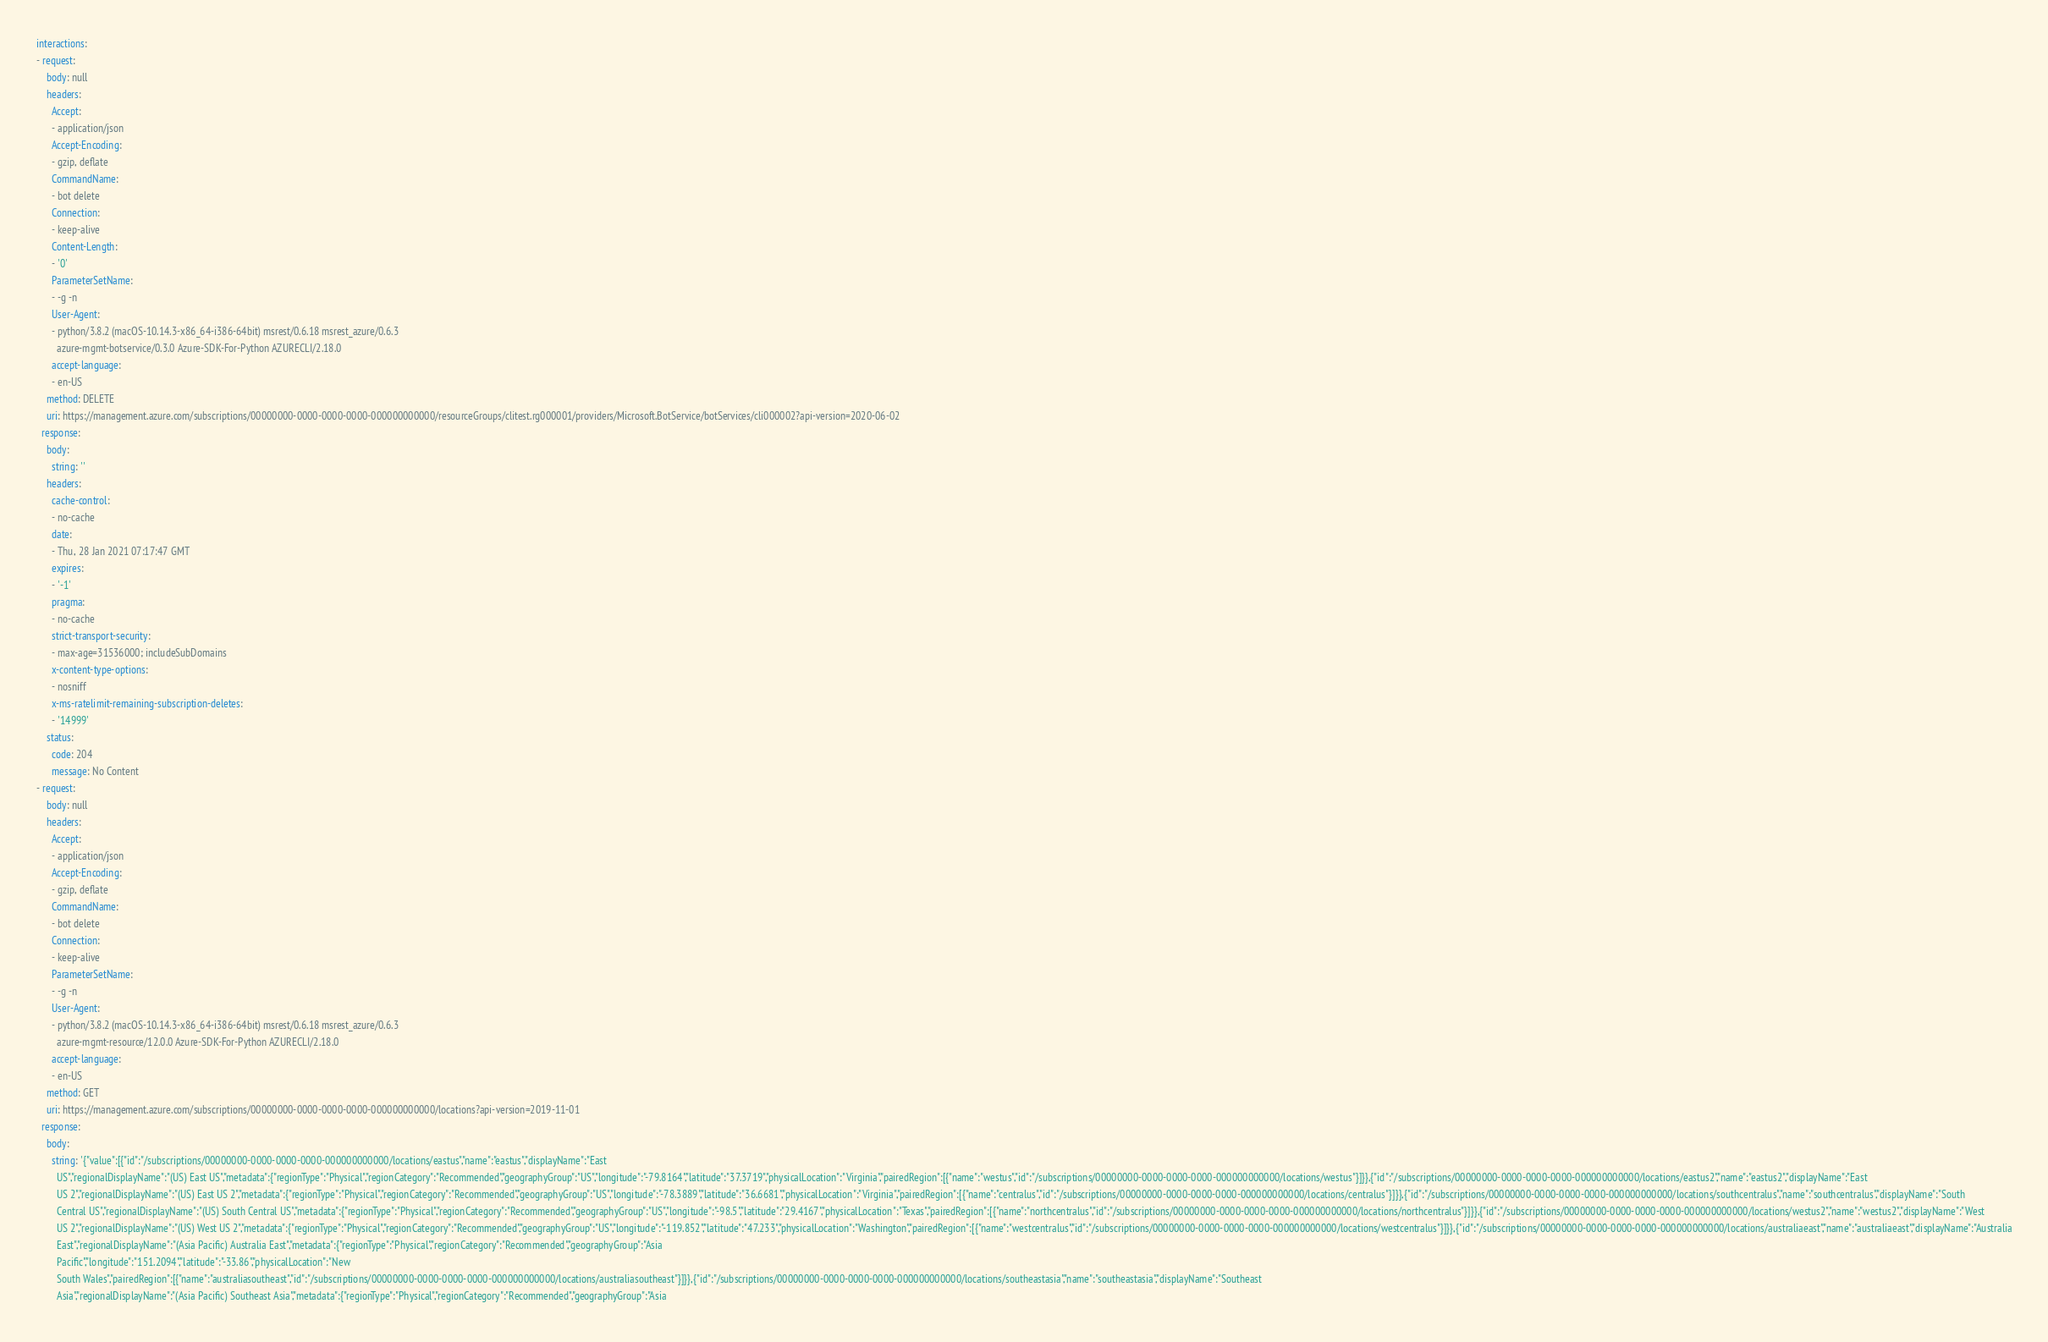Convert code to text. <code><loc_0><loc_0><loc_500><loc_500><_YAML_>interactions:
- request:
    body: null
    headers:
      Accept:
      - application/json
      Accept-Encoding:
      - gzip, deflate
      CommandName:
      - bot delete
      Connection:
      - keep-alive
      Content-Length:
      - '0'
      ParameterSetName:
      - -g -n
      User-Agent:
      - python/3.8.2 (macOS-10.14.3-x86_64-i386-64bit) msrest/0.6.18 msrest_azure/0.6.3
        azure-mgmt-botservice/0.3.0 Azure-SDK-For-Python AZURECLI/2.18.0
      accept-language:
      - en-US
    method: DELETE
    uri: https://management.azure.com/subscriptions/00000000-0000-0000-0000-000000000000/resourceGroups/clitest.rg000001/providers/Microsoft.BotService/botServices/cli000002?api-version=2020-06-02
  response:
    body:
      string: ''
    headers:
      cache-control:
      - no-cache
      date:
      - Thu, 28 Jan 2021 07:17:47 GMT
      expires:
      - '-1'
      pragma:
      - no-cache
      strict-transport-security:
      - max-age=31536000; includeSubDomains
      x-content-type-options:
      - nosniff
      x-ms-ratelimit-remaining-subscription-deletes:
      - '14999'
    status:
      code: 204
      message: No Content
- request:
    body: null
    headers:
      Accept:
      - application/json
      Accept-Encoding:
      - gzip, deflate
      CommandName:
      - bot delete
      Connection:
      - keep-alive
      ParameterSetName:
      - -g -n
      User-Agent:
      - python/3.8.2 (macOS-10.14.3-x86_64-i386-64bit) msrest/0.6.18 msrest_azure/0.6.3
        azure-mgmt-resource/12.0.0 Azure-SDK-For-Python AZURECLI/2.18.0
      accept-language:
      - en-US
    method: GET
    uri: https://management.azure.com/subscriptions/00000000-0000-0000-0000-000000000000/locations?api-version=2019-11-01
  response:
    body:
      string: '{"value":[{"id":"/subscriptions/00000000-0000-0000-0000-000000000000/locations/eastus","name":"eastus","displayName":"East
        US","regionalDisplayName":"(US) East US","metadata":{"regionType":"Physical","regionCategory":"Recommended","geographyGroup":"US","longitude":"-79.8164","latitude":"37.3719","physicalLocation":"Virginia","pairedRegion":[{"name":"westus","id":"/subscriptions/00000000-0000-0000-0000-000000000000/locations/westus"}]}},{"id":"/subscriptions/00000000-0000-0000-0000-000000000000/locations/eastus2","name":"eastus2","displayName":"East
        US 2","regionalDisplayName":"(US) East US 2","metadata":{"regionType":"Physical","regionCategory":"Recommended","geographyGroup":"US","longitude":"-78.3889","latitude":"36.6681","physicalLocation":"Virginia","pairedRegion":[{"name":"centralus","id":"/subscriptions/00000000-0000-0000-0000-000000000000/locations/centralus"}]}},{"id":"/subscriptions/00000000-0000-0000-0000-000000000000/locations/southcentralus","name":"southcentralus","displayName":"South
        Central US","regionalDisplayName":"(US) South Central US","metadata":{"regionType":"Physical","regionCategory":"Recommended","geographyGroup":"US","longitude":"-98.5","latitude":"29.4167","physicalLocation":"Texas","pairedRegion":[{"name":"northcentralus","id":"/subscriptions/00000000-0000-0000-0000-000000000000/locations/northcentralus"}]}},{"id":"/subscriptions/00000000-0000-0000-0000-000000000000/locations/westus2","name":"westus2","displayName":"West
        US 2","regionalDisplayName":"(US) West US 2","metadata":{"regionType":"Physical","regionCategory":"Recommended","geographyGroup":"US","longitude":"-119.852","latitude":"47.233","physicalLocation":"Washington","pairedRegion":[{"name":"westcentralus","id":"/subscriptions/00000000-0000-0000-0000-000000000000/locations/westcentralus"}]}},{"id":"/subscriptions/00000000-0000-0000-0000-000000000000/locations/australiaeast","name":"australiaeast","displayName":"Australia
        East","regionalDisplayName":"(Asia Pacific) Australia East","metadata":{"regionType":"Physical","regionCategory":"Recommended","geographyGroup":"Asia
        Pacific","longitude":"151.2094","latitude":"-33.86","physicalLocation":"New
        South Wales","pairedRegion":[{"name":"australiasoutheast","id":"/subscriptions/00000000-0000-0000-0000-000000000000/locations/australiasoutheast"}]}},{"id":"/subscriptions/00000000-0000-0000-0000-000000000000/locations/southeastasia","name":"southeastasia","displayName":"Southeast
        Asia","regionalDisplayName":"(Asia Pacific) Southeast Asia","metadata":{"regionType":"Physical","regionCategory":"Recommended","geographyGroup":"Asia</code> 